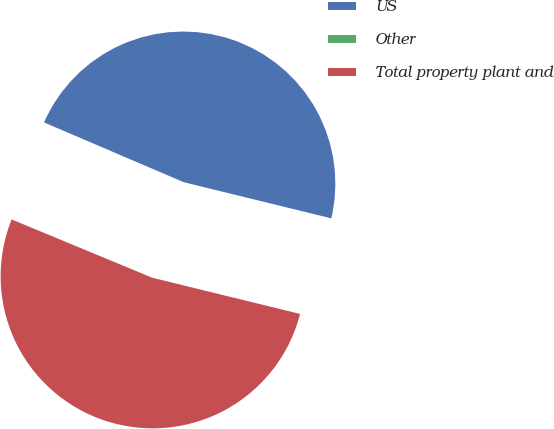Convert chart. <chart><loc_0><loc_0><loc_500><loc_500><pie_chart><fcel>US<fcel>Other<fcel>Total property plant and<nl><fcel>47.39%<fcel>0.18%<fcel>52.43%<nl></chart> 